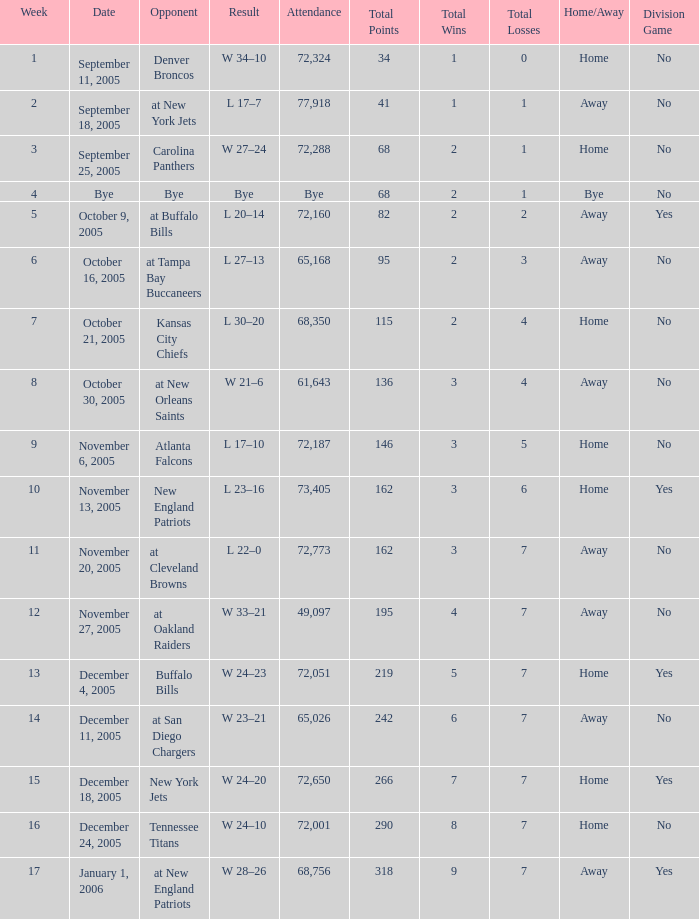On what Date was the Attendance 73,405? November 13, 2005. 